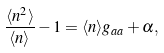<formula> <loc_0><loc_0><loc_500><loc_500>\frac { \langle n ^ { 2 } \rangle } { \langle n \rangle } - 1 = \langle n \rangle g _ { a a } + \alpha ,</formula> 